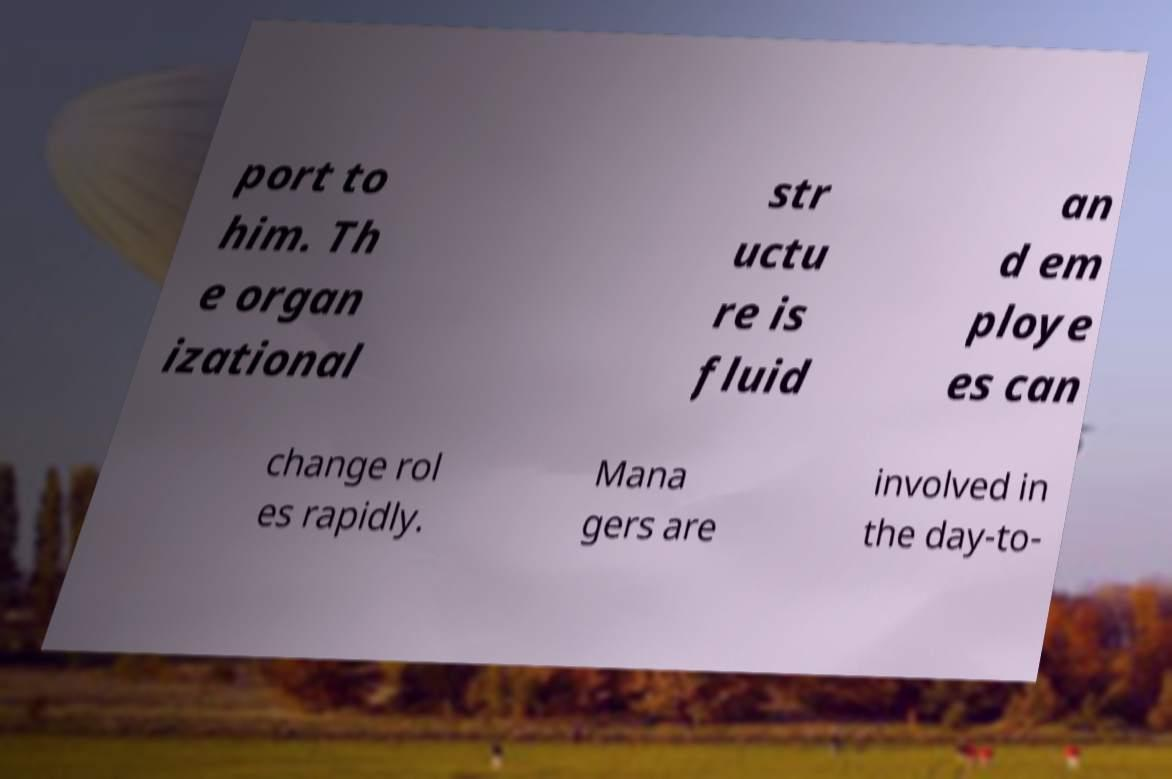Please identify and transcribe the text found in this image. port to him. Th e organ izational str uctu re is fluid an d em ploye es can change rol es rapidly. Mana gers are involved in the day-to- 